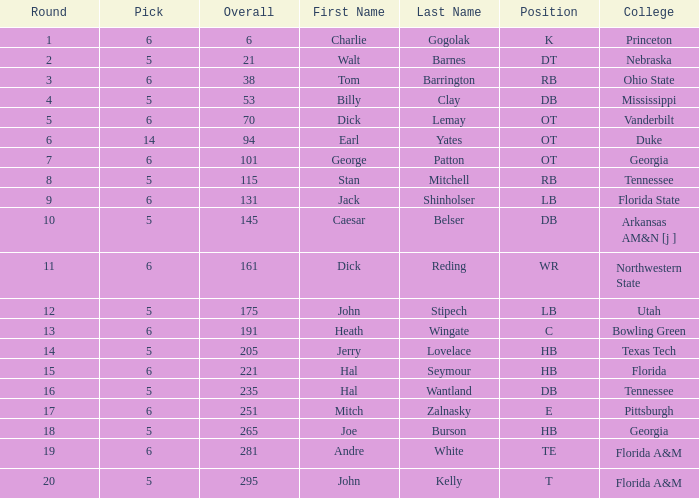What is the sum of Overall, when Pick is greater than 5, when Round is less than 11, and when Name is "Tom Barrington"? 38.0. 